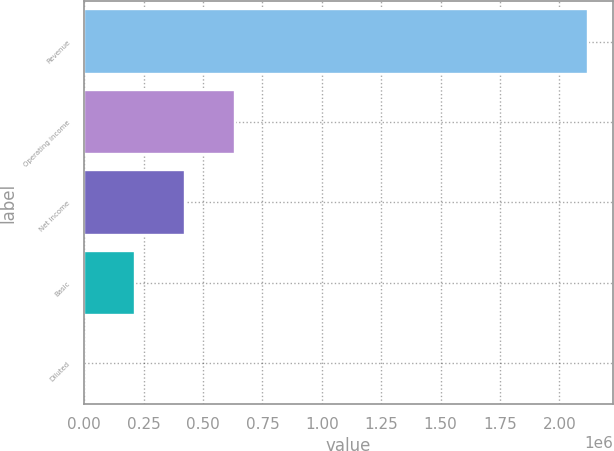Convert chart to OTSL. <chart><loc_0><loc_0><loc_500><loc_500><bar_chart><fcel>Revenue<fcel>Operating income<fcel>Net income<fcel>Basic<fcel>Diluted<nl><fcel>2.11946e+06<fcel>635837<fcel>423892<fcel>211946<fcel>0.65<nl></chart> 